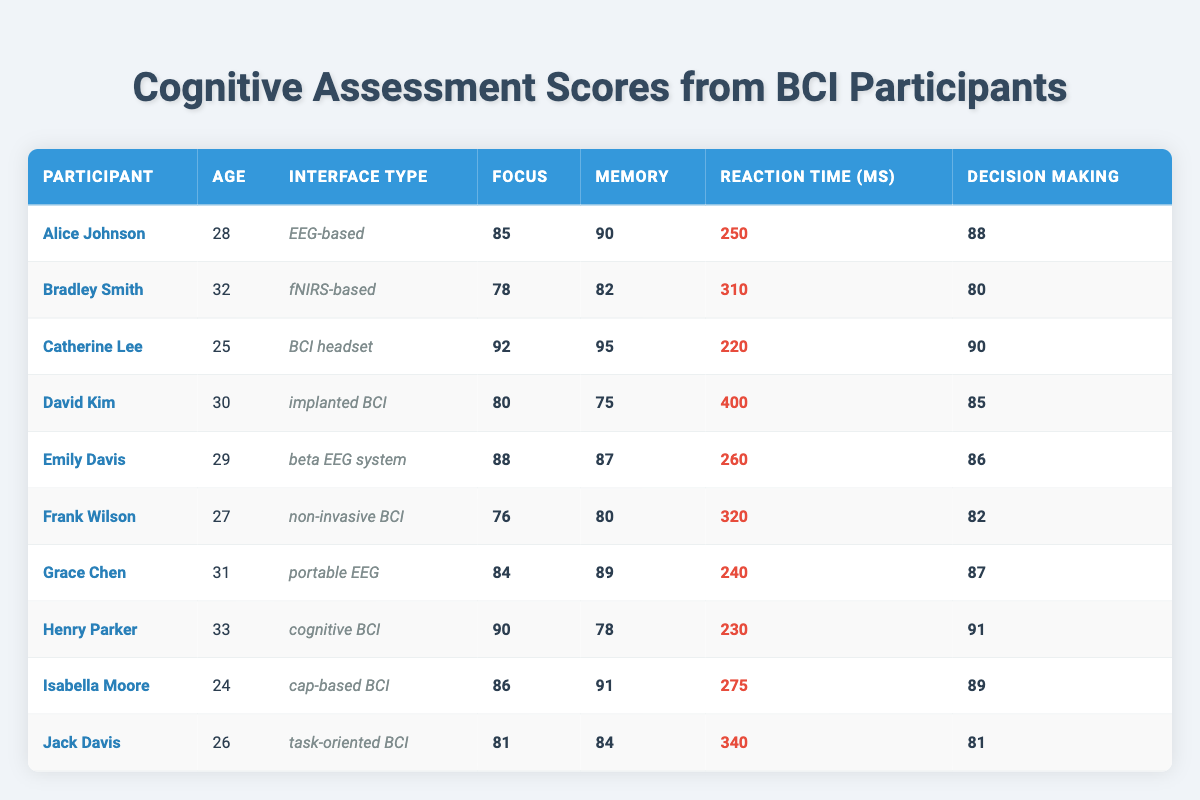What is the cognitive assessment score for memory of Catherine Lee? Catherine Lee's memory score is found in the table under her name, listed as 95.
Answer: 95 What is the age of the participant with the highest decision-making score? The highest decision-making score in the table is 91, belonging to Henry Parker, who is 33 years old.
Answer: 33 Which participant has the lowest focus score? The lowest focus score in the table is 76, recorded for Frank Wilson.
Answer: Frank Wilson What is the average reaction time of all participants? To calculate the average, sum the reaction times: (250 + 310 + 220 + 400 + 260 + 320 + 240 + 230 + 275 + 340) = 2805. There are 10 participants, so the average is 2805 / 10 = 280.5 ms.
Answer: 280.5 ms Does Emily Davis have a higher focus score than David Kim? Emily Davis has a focus score of 88, while David Kim has a score of 80. Since 88 is greater than 80, the statement is true.
Answer: Yes What is the total decision-making score of all participants? To find the total, add all decision-making scores: 88 + 80 + 90 + 85 + 86 + 82 + 87 + 91 + 89 + 81 =  879.
Answer: 879 Which participant aged 30 or older has the highest memory score? The participants aged 30 or older are Bradley Smith (age 32, memory 82), David Kim (age 30, memory 75), and Henry Parker (age 33, memory 78). Among these, the highest memory score is 82 from Bradley Smith.
Answer: Bradley Smith Are there any participants whose focus scores are above 90? Yes, both Catherine Lee (92) and Henry Parker (90) have focus scores above 90.
Answer: Yes What is the difference between the highest and lowest memory scores? The highest memory score is 95 (Catherine Lee) and the lowest is 75 (David Kim). The difference is 95 - 75 = 20.
Answer: 20 Which brain-computer interface type had participants with an average focus score of more than 85? Calculate averages for each interface type: EEG-based (85), fNIRS-based (78), BCI headset (92), implanted BCI (80), beta EEG system (88), non-invasive BCI (76), portable EEG (84), cognitive BCI (90), cap-based BCI (86), and task-oriented BCI (81). EEG-based, BCI headset, beta EEG system, cognitive BCI, and cap-based BCI have average scores above 85.
Answer: EEG-based, BCI headset, beta EEG system, cognitive BCI, cap-based BCI 